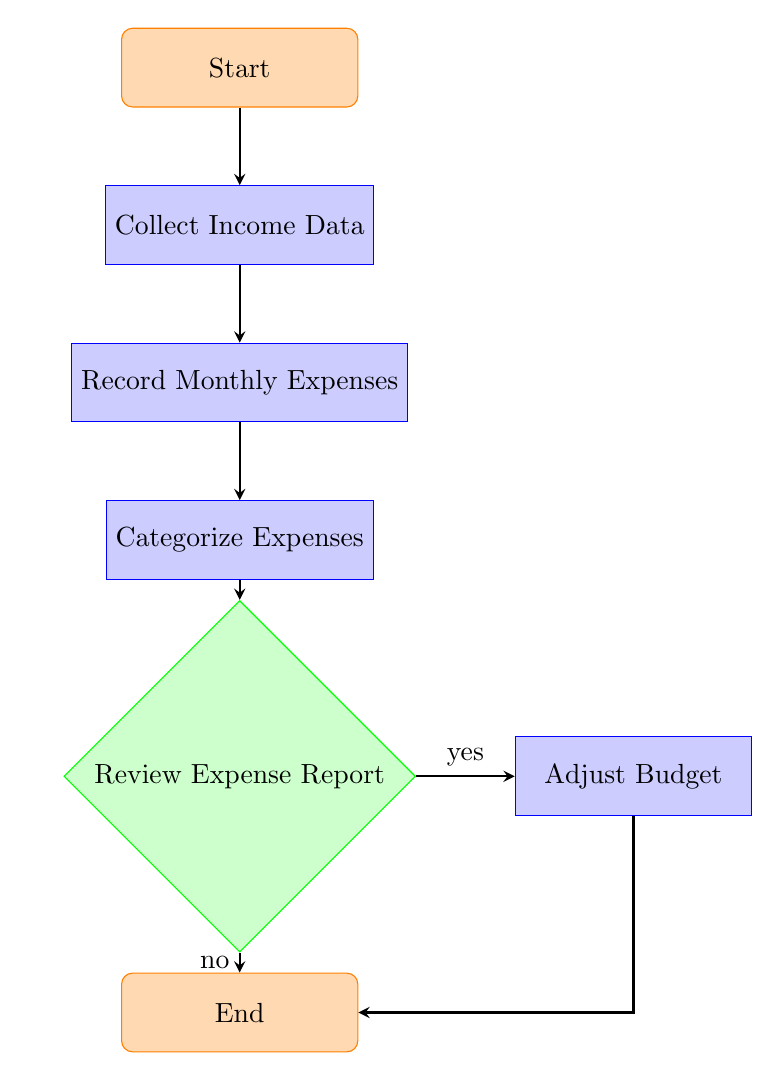What is the first step in the process? The diagram indicates that the first step is the "Start" node, which leads to the collection of income data.
Answer: Start How many process nodes are in the diagram? The diagram includes three process nodes: "Collect Income Data," "Record Monthly Expenses," and "Categorize Expenses."
Answer: 3 What happens after "Categorize Expenses"? Following "Categorize Expenses," the next step in the flow is the "Review Expense Report" decision node.
Answer: Review Expense Report What decision comes after reviewing the expense report? After reviewing the expense report, the decision made is either to "Adjust Budget" or to end the process, with the answer being based on the review outcome.
Answer: Adjust Budget or End What is the outcome if the decision is 'no' after the review? If the decision is 'no' after the review, the flow proceeds directly to the "End" node, concluding the process.
Answer: End How many arrows are present in the diagram? The diagram shows a total of six arrows connecting the nodes, facilitating the flow of the expense tracking process.
Answer: 6 Is it necessary to adjust the budget after reviewing the expense report? Adjusting the budget is only necessary if the review decision is 'yes'; otherwise, the process ends without adjustment.
Answer: No (if 'no'), Yes (if 'yes') Which node is directly connected to the "Review Expense Report" node? The "Review Expense Report" node is directly connected to the "Categorize Expenses" node, leading up to it in the flow.
Answer: Categorize Expenses What process follows the adjustment of the budget? Following the adjustment of the budget, the next step in the flow is the "End" node, indicating the conclusion of the process.
Answer: End 